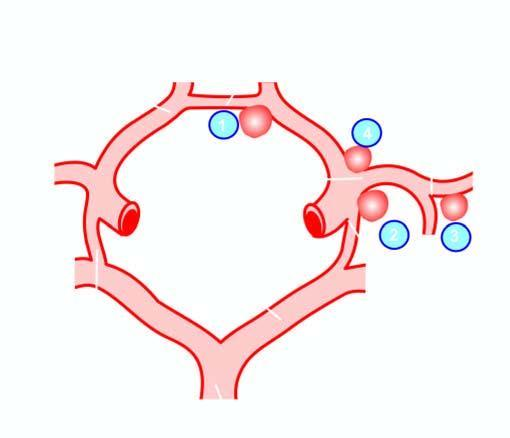what indicate the frequency of involvement?
Answer the question using a single word or phrase. Serial numbers 